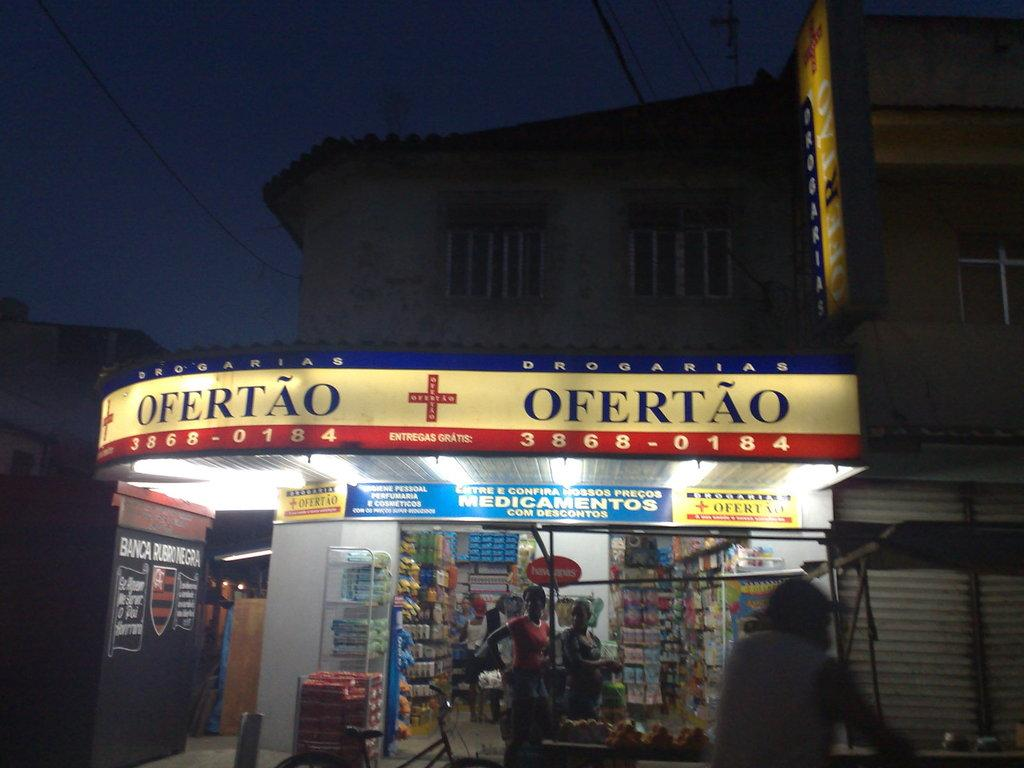<image>
Summarize the visual content of the image. A CORNER STORE WITH THE SIGNBOARD "OFERTAO 3868-0184" 